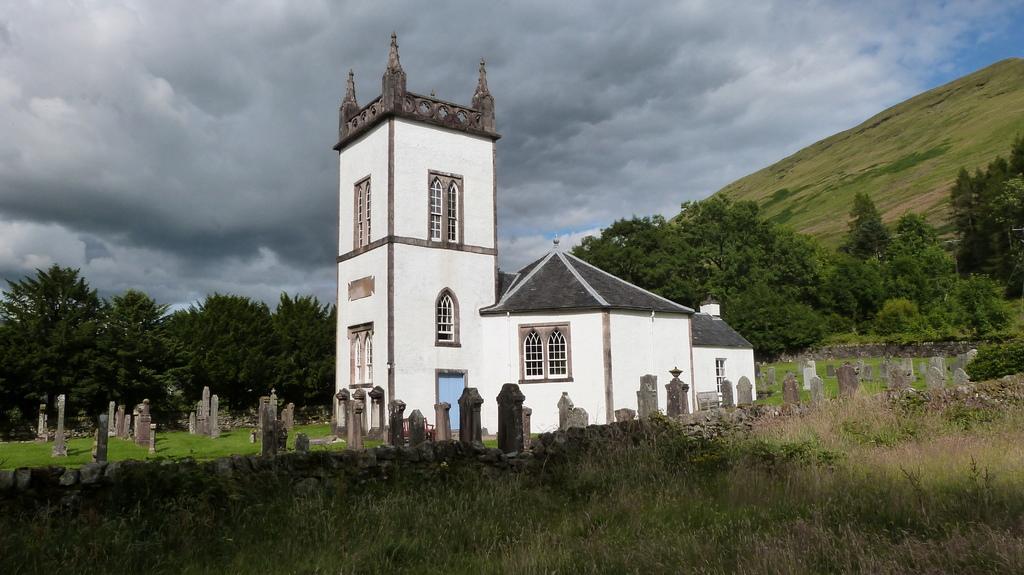How would you summarize this image in a sentence or two? In the center of the image we can see graveyard and building. At the bottom of the image we can see grass and plants. In the background we can see trees, hill, clouds and sky. 